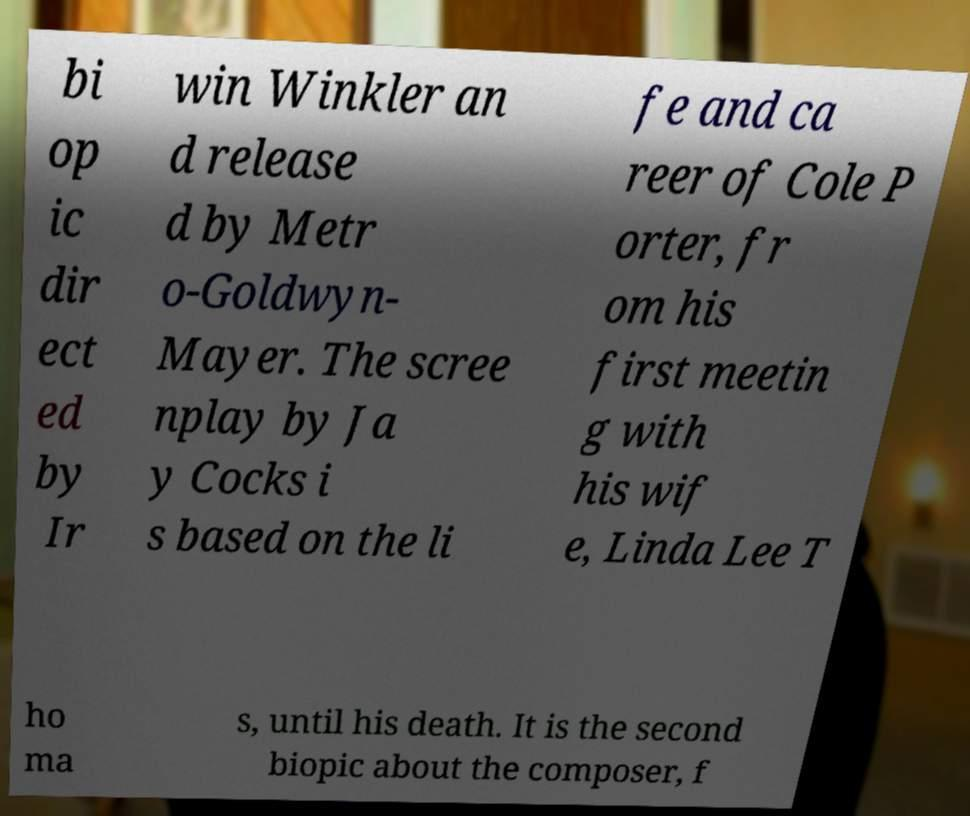Can you read and provide the text displayed in the image?This photo seems to have some interesting text. Can you extract and type it out for me? bi op ic dir ect ed by Ir win Winkler an d release d by Metr o-Goldwyn- Mayer. The scree nplay by Ja y Cocks i s based on the li fe and ca reer of Cole P orter, fr om his first meetin g with his wif e, Linda Lee T ho ma s, until his death. It is the second biopic about the composer, f 